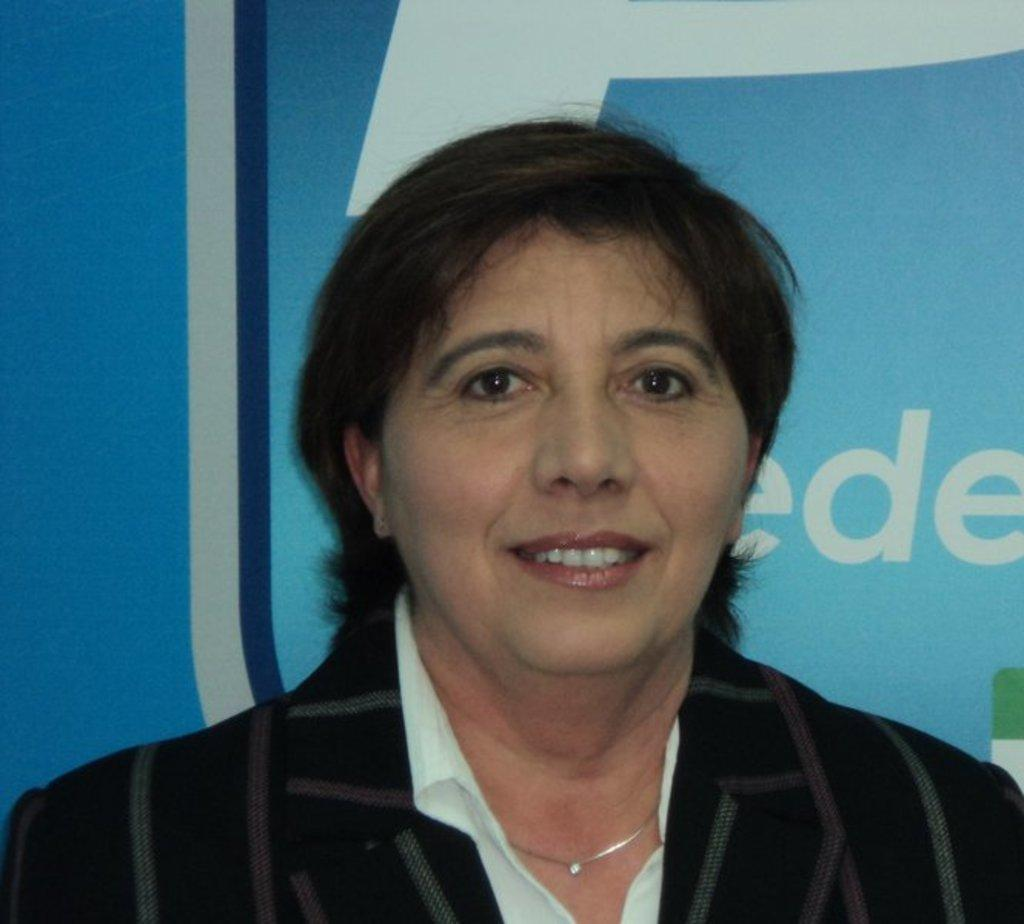Who is present in the image? There is a woman in the image. What is the woman's facial expression? The woman is smiling. What else can be seen in the image besides the woman? There is text visible in the background of the image. What type of powder is being used by the woman in the image? There is no powder visible in the image, and the woman is not using any powder. What type of cord is connected to the woman's clothing in the image? There is no cord connected to the woman's clothing in the image. 